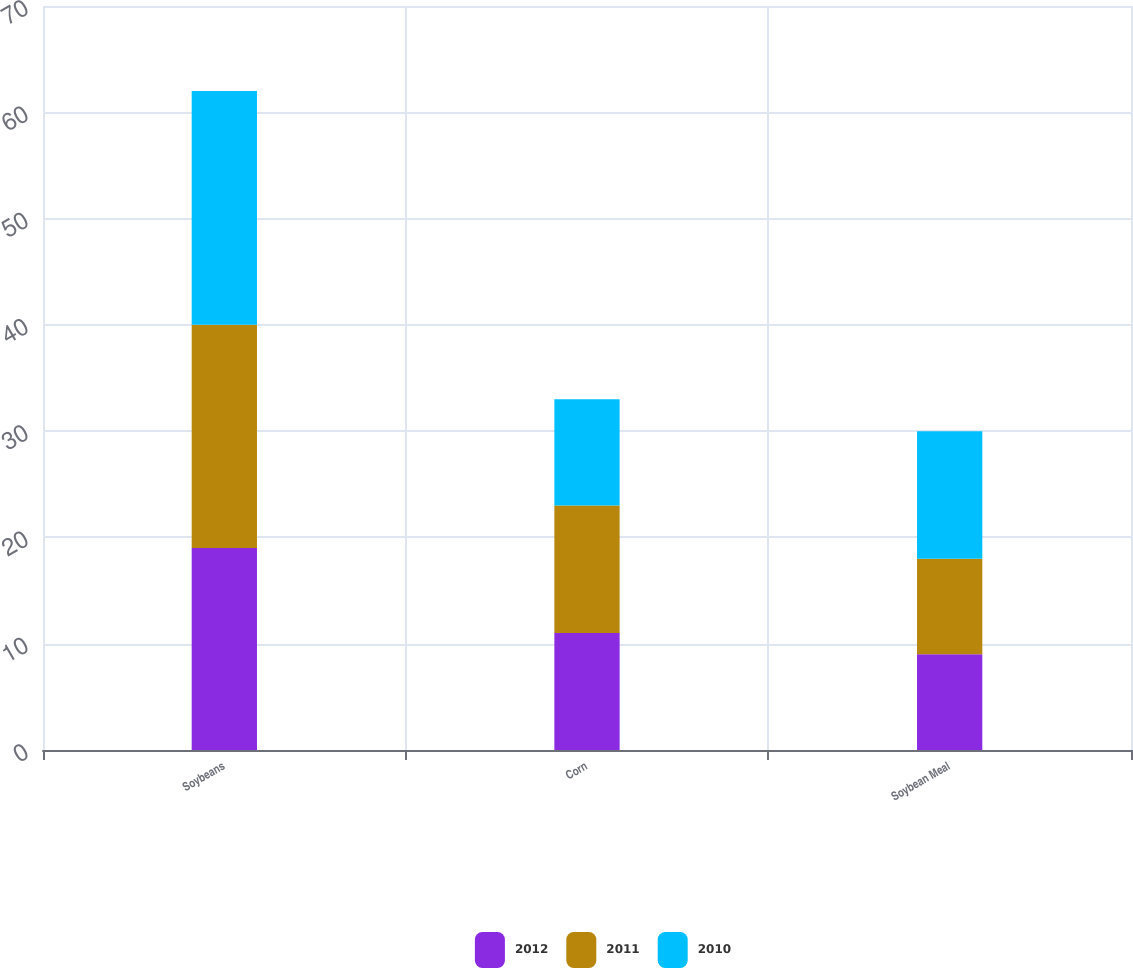Convert chart to OTSL. <chart><loc_0><loc_0><loc_500><loc_500><stacked_bar_chart><ecel><fcel>Soybeans<fcel>Corn<fcel>Soybean Meal<nl><fcel>2012<fcel>19<fcel>11<fcel>9<nl><fcel>2011<fcel>21<fcel>12<fcel>9<nl><fcel>2010<fcel>22<fcel>10<fcel>12<nl></chart> 